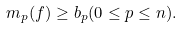Convert formula to latex. <formula><loc_0><loc_0><loc_500><loc_500>m _ { p } ( f ) \geq b _ { p } ( 0 \leq p \leq n ) .</formula> 